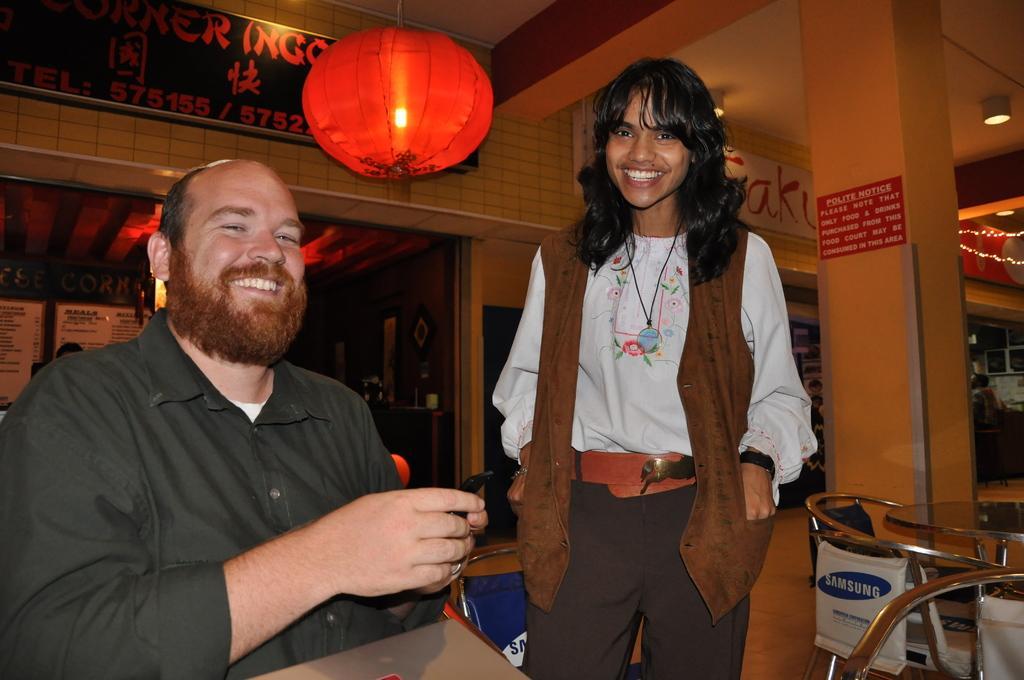Please provide a concise description of this image. In the center of the image a lady is standing. On the left side of the image a man is sitting and holding an object. On the right side of the image we can see table, chairs, boards, wall, lights are there. In the background of the image we can see door, wall, boards, lights are there. At the top of the image there is a roof. At the bottom of the image there is a floor. 